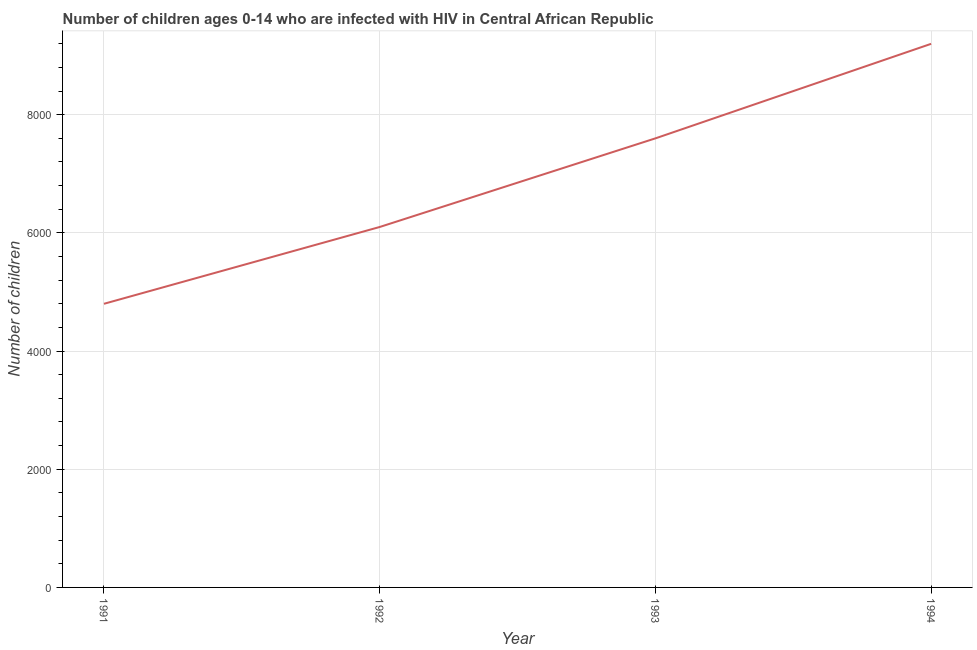What is the number of children living with hiv in 1994?
Keep it short and to the point. 9200. Across all years, what is the maximum number of children living with hiv?
Your answer should be compact. 9200. Across all years, what is the minimum number of children living with hiv?
Provide a succinct answer. 4800. In which year was the number of children living with hiv minimum?
Keep it short and to the point. 1991. What is the sum of the number of children living with hiv?
Give a very brief answer. 2.77e+04. What is the difference between the number of children living with hiv in 1993 and 1994?
Your answer should be compact. -1600. What is the average number of children living with hiv per year?
Ensure brevity in your answer.  6925. What is the median number of children living with hiv?
Provide a succinct answer. 6850. Do a majority of the years between 1994 and 1991 (inclusive) have number of children living with hiv greater than 6000 ?
Your answer should be compact. Yes. What is the ratio of the number of children living with hiv in 1993 to that in 1994?
Provide a short and direct response. 0.83. Is the difference between the number of children living with hiv in 1991 and 1992 greater than the difference between any two years?
Keep it short and to the point. No. What is the difference between the highest and the second highest number of children living with hiv?
Your answer should be very brief. 1600. Is the sum of the number of children living with hiv in 1991 and 1992 greater than the maximum number of children living with hiv across all years?
Offer a very short reply. Yes. What is the difference between the highest and the lowest number of children living with hiv?
Keep it short and to the point. 4400. In how many years, is the number of children living with hiv greater than the average number of children living with hiv taken over all years?
Give a very brief answer. 2. How many lines are there?
Your response must be concise. 1. What is the difference between two consecutive major ticks on the Y-axis?
Offer a very short reply. 2000. Does the graph contain any zero values?
Offer a terse response. No. Does the graph contain grids?
Your response must be concise. Yes. What is the title of the graph?
Your answer should be very brief. Number of children ages 0-14 who are infected with HIV in Central African Republic. What is the label or title of the Y-axis?
Offer a terse response. Number of children. What is the Number of children in 1991?
Your response must be concise. 4800. What is the Number of children in 1992?
Give a very brief answer. 6100. What is the Number of children of 1993?
Offer a very short reply. 7600. What is the Number of children in 1994?
Provide a short and direct response. 9200. What is the difference between the Number of children in 1991 and 1992?
Make the answer very short. -1300. What is the difference between the Number of children in 1991 and 1993?
Your answer should be very brief. -2800. What is the difference between the Number of children in 1991 and 1994?
Your answer should be very brief. -4400. What is the difference between the Number of children in 1992 and 1993?
Ensure brevity in your answer.  -1500. What is the difference between the Number of children in 1992 and 1994?
Make the answer very short. -3100. What is the difference between the Number of children in 1993 and 1994?
Your answer should be very brief. -1600. What is the ratio of the Number of children in 1991 to that in 1992?
Ensure brevity in your answer.  0.79. What is the ratio of the Number of children in 1991 to that in 1993?
Your answer should be compact. 0.63. What is the ratio of the Number of children in 1991 to that in 1994?
Provide a short and direct response. 0.52. What is the ratio of the Number of children in 1992 to that in 1993?
Your answer should be very brief. 0.8. What is the ratio of the Number of children in 1992 to that in 1994?
Ensure brevity in your answer.  0.66. What is the ratio of the Number of children in 1993 to that in 1994?
Offer a very short reply. 0.83. 